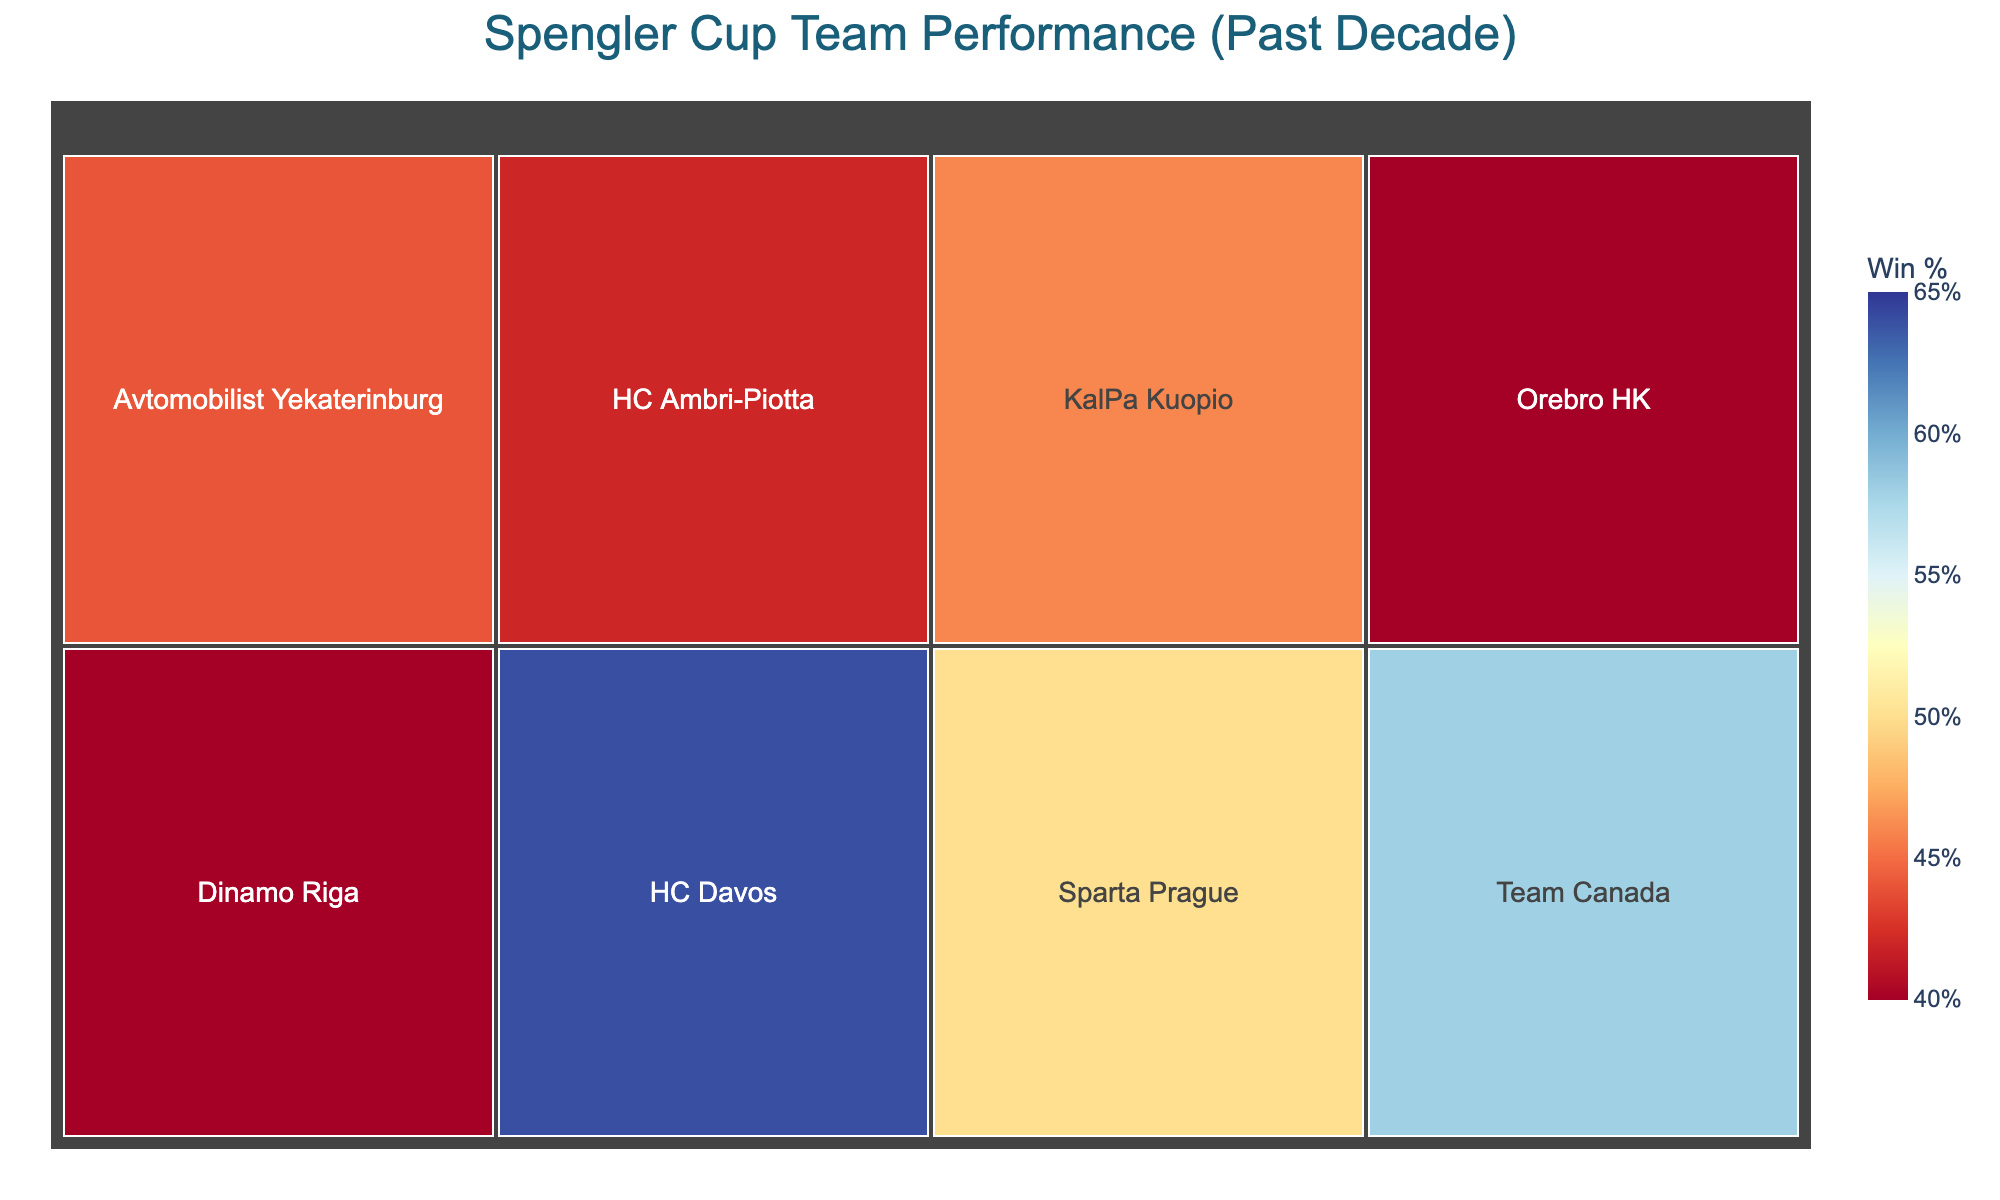What team has the highest goal differential? By looking at the goal differential for each team, we can see that HC Davos has the goal differential of 45, which is the highest in the figure.
Answer: HC Davos Which team has the highest win percentage? The win percentage is calculated using Wins and Total Games. Among the teams, HC Davos has the highest win percentage since they have the highest number of wins relative to their total games.
Answer: HC Davos Which team has the most losses? By examining the losses for each team, Dinamo Riga has the most losses with a total of 30.
Answer: Dinamo Riga How many total games did Sparta Prague play? Total games are calculated by adding Wins and Losses for Sparta Prague. It is 25 + 25 = 50.
Answer: 50 What is the win percentage of Team Canada? The win percentage is calculated as (Wins/Total_Games) * 100. For Team Canada, it's (29/50) * 100 = 58%.
Answer: 58% Which team has the lowest win percentage? Analyze the win percentages of each team, and Orebro HK has the lowest win percentage.
Answer: Orebro HK Who scored more goals: HC Ambri-Piotta or KalPa Kuopio? We can't directly determine goals scored but can infer from goal differential. Since HC Ambri-Piotta has a more negative differential, KalPa Kuopio is likely to have scored more.
Answer: KalPa Kuopio Which team played the fewest games? The team with the smallest area (total games) in the treemap is HC Ambri-Piotta, which suggests they played the fewest number of games.
Answer: HC Ambri-Piotta Between Team Canada and Avtomobilist Yekaterinburg, which has better performance in terms of wins? Compare the wins of both teams; Team Canada has 29 wins while Avtomobilist Yekaterinburg has 22 wins.
Answer: Team Canada 